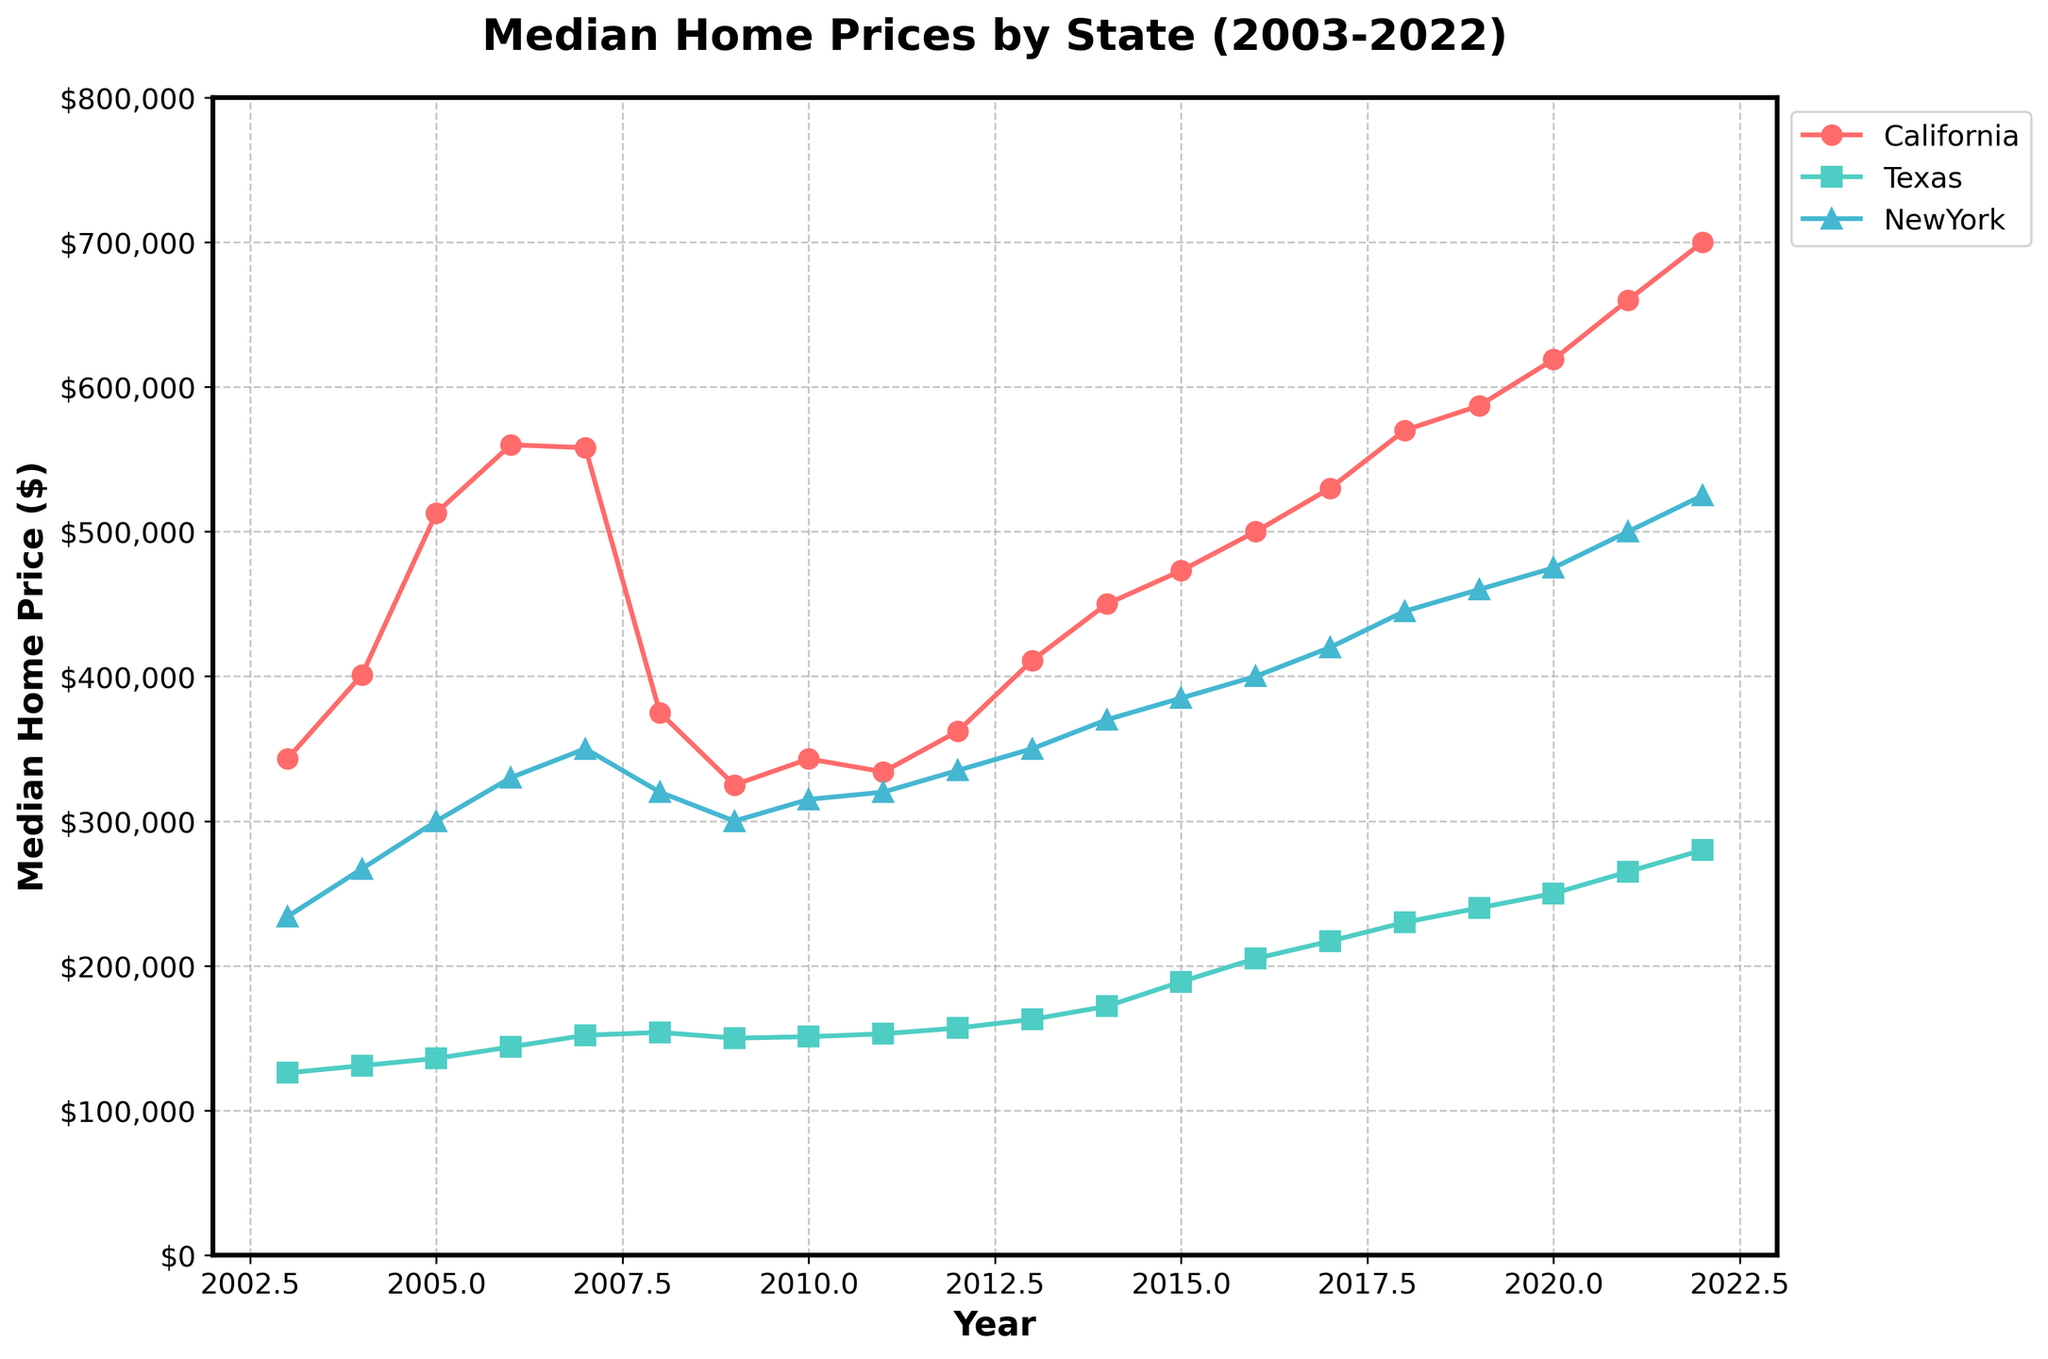Which state had the highest median home price in 2022? From the figure, locate the values for each state in 2022. Compare the median home prices for California, Texas, and New York. California shows the highest median price.
Answer: California What is the median home price trend in California from 2009 to 2012? Observe the values at the markers for California from 2009 to 2012. The trend starts from $325,000 in 2009 and ends at $362,000 in 2012. It shows a generally increasing trend with a dip in 2011.
Answer: Increasing By how much did the median home price in Texas increase from 2003 to 2022? Identify and subtract the 2003 value from the 2022 value for Texas. The values are $280,000 in 2022 and $126,000 in 2003. The difference is $280,000 - $126,000, which gives us the increase amount.
Answer: $154,000 How do the median home prices in New York compared between 2007 and 2009? Locate and compare the data points for New York in 2007 and 2009. The median home price was $350,000 in 2007 and $300,000 in 2009, showing a decrease.
Answer: Decreased Which state experienced the largest drop in median home price during the 2008 financial crisis (2007 to 2009)? Compare the changes between 2007 and 2009 for all states. California dropped from $558,000 to $325,000, while Texas dropped from $152,000 to $150,000 and New York from $350,000 to $300,000. California had the largest drop of $233,000.
Answer: California What was the overall trend for median home prices in New York from 2009 to 2022? Examine the trend line for New York from 2009 to 2022. Start from $300,000 in 2009 and trace to $525,000 in 2022, which shows a continuous upward trend.
Answer: Increasing How did the median home price in California in 2022 compare to that in New York in 2022? Find and compare the data points for California and New York in 2022. California had $700,000 and New York had $525,000, showing that California's median home price was higher.
Answer: California's median home price is higher What is the average increase in median home prices for Texas per year from 2010 to 2022? Calculate the total increase by subtracting the 2010 value from the 2022 value for Texas, then divide by the number of years. The values are $151,000 in 2010 and $280,000 in 2022, resulting in a difference of $129,000 over 12 years ($129,000/12).
Answer: $10,750 per year Which state showed the steadiest increase in median home prices over the 20 years? Evaluate the consistency of the trend lines for all states from 2003 to 2022. Texas exhibits a more steady, gradual increase compared to the more fluctuating lines of California and New York.
Answer: Texas 